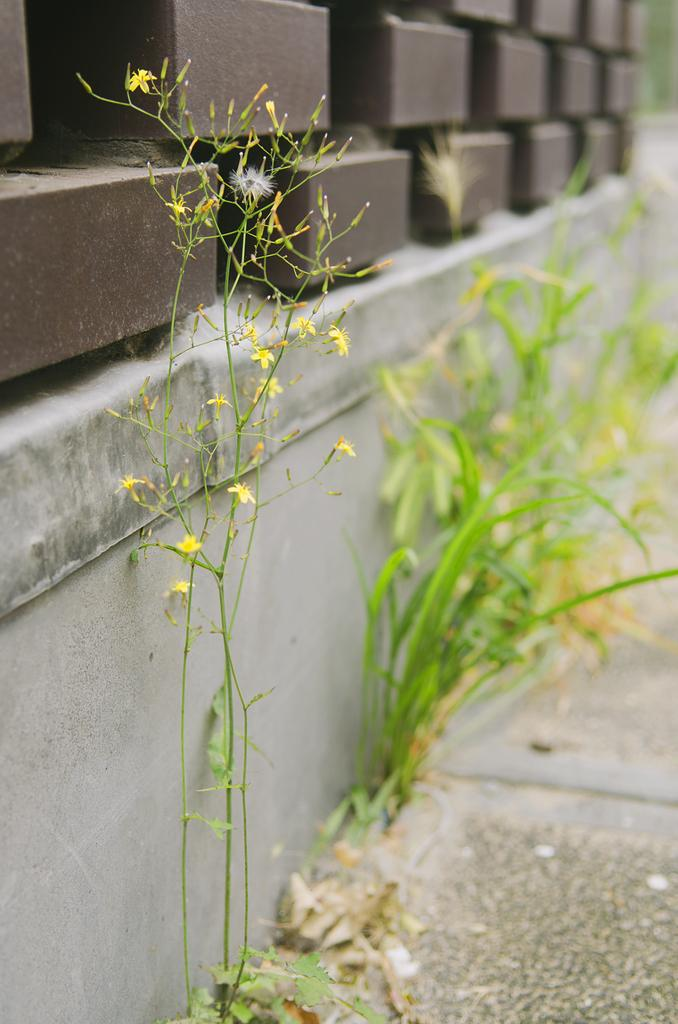What type of plant is visible in the image? There is a plant with yellow flowers in the image. What can be seen in the background of the image? There is grass and a wall in the background of the image. What material is the wall made of? The wall is made of bricks in the background of the image. What type of instrument is being played in the background of the image? There is no instrument being played in the image; it only features a plant, grass, a wall, and bricks. 